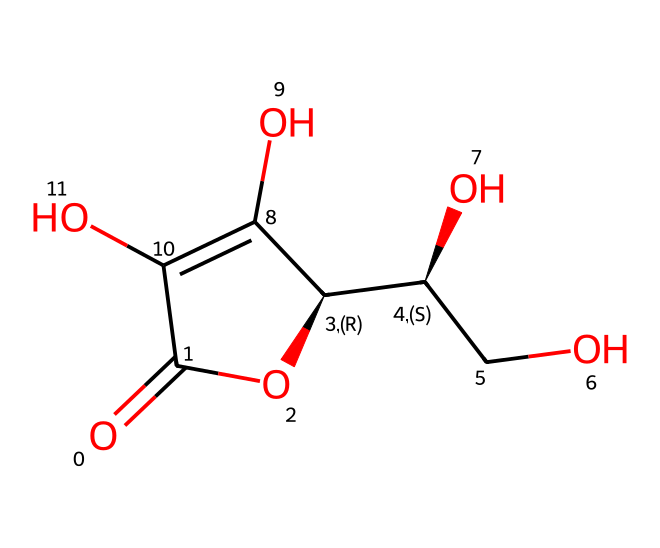What is the molecular formula for ascorbic acid? To deduce the molecular formula, count the number of various atoms in the chemical structure represented by the SMILES notation. The compound has six carbon (C) atoms, eight hydrogen (H) atoms, and six oxygen (O) atoms, leading to the formula C6H8O6.
Answer: C6H8O6 How many rings are present in the structure of ascorbic acid? By analyzing the SMILES representation, we observe that there is one ring indicated by the notation "C1". The structure indeed contains a single cyclic portion.
Answer: 1 What functional groups are present in ascorbic acid? Reviewing the structure reveals hydroxyl groups (-OH) and a carbonyl group (C=O), which are characteristic of polyhydroxy compounds.
Answer: hydroxyl, carbonyl Is ascorbic acid a reducing agent? Ascorbic acid possesses a structure that allows it to donate electrons easily, thus functioning as a reducing agent in chemical reactions, particularly in its antioxidant capacity.
Answer: yes What type of compound is ascorbic acid classified as? Analyzing the structure, ascorbic acid contains multiple hydroxyl groups and is a type of carbohydrate, specifically a sugar acid, as well as being an antioxidant.
Answer: sugar acid How does the presence of hydroxyl groups affect the solubility of ascorbic acid? The hydroxyl groups increase the polarity of ascorbic acid, facilitating hydrogen bonding with water, thereby enhancing its solubility in aqueous solutions.
Answer: increases solubility 